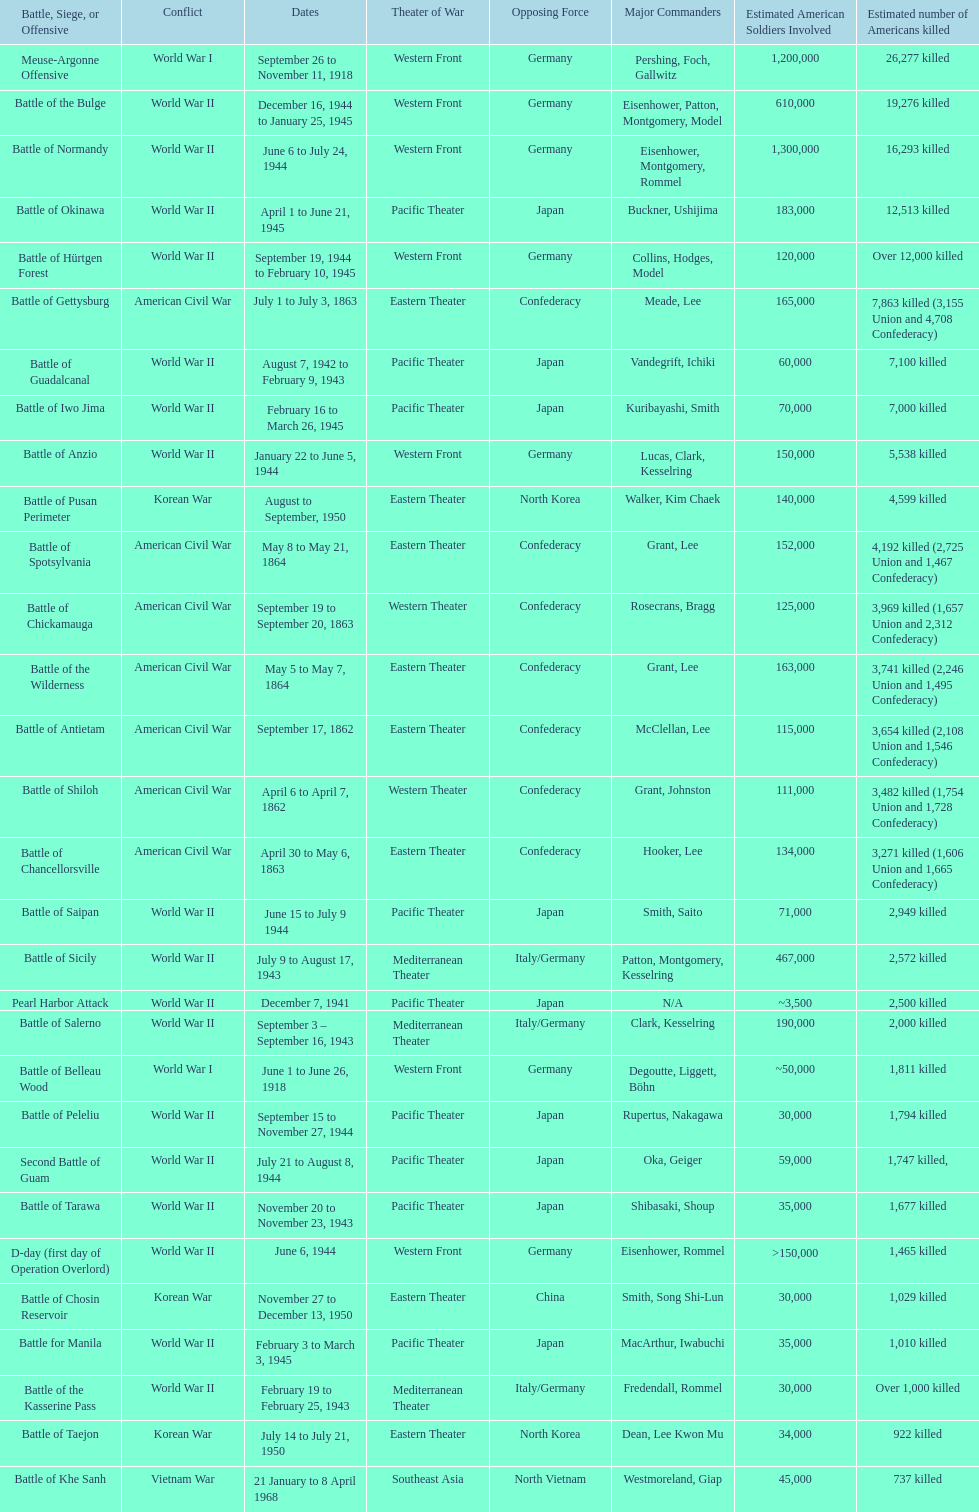How many battles resulted between 3,000 and 4,200 estimated americans killed? 6. Parse the table in full. {'header': ['Battle, Siege, or Offensive', 'Conflict', 'Dates', 'Theater of War', 'Opposing Force', 'Major Commanders', 'Estimated American Soldiers Involved', 'Estimated number of Americans killed'], 'rows': [['Meuse-Argonne Offensive', 'World War I', 'September 26 to November 11, 1918', 'Western Front', 'Germany', 'Pershing, Foch, Gallwitz', '1,200,000', '26,277 killed'], ['Battle of the Bulge', 'World War II', 'December 16, 1944 to January 25, 1945', 'Western Front', 'Germany', 'Eisenhower, Patton, Montgomery, Model', '610,000', '19,276 killed'], ['Battle of Normandy', 'World War II', 'June 6 to July 24, 1944', 'Western Front', 'Germany', 'Eisenhower, Montgomery, Rommel', '1,300,000', '16,293 killed'], ['Battle of Okinawa', 'World War II', 'April 1 to June 21, 1945', 'Pacific Theater', 'Japan', 'Buckner, Ushijima', '183,000', '12,513 killed'], ['Battle of Hürtgen Forest', 'World War II', 'September 19, 1944 to February 10, 1945', 'Western Front', 'Germany', 'Collins, Hodges, Model', '120,000', 'Over 12,000 killed'], ['Battle of Gettysburg', 'American Civil War', 'July 1 to July 3, 1863', 'Eastern Theater', 'Confederacy', 'Meade, Lee', '165,000', '7,863 killed (3,155 Union and 4,708 Confederacy)'], ['Battle of Guadalcanal', 'World War II', 'August 7, 1942 to February 9, 1943', 'Pacific Theater', 'Japan', 'Vandegrift, Ichiki', '60,000', '7,100 killed'], ['Battle of Iwo Jima', 'World War II', 'February 16 to March 26, 1945', 'Pacific Theater', 'Japan', 'Kuribayashi, Smith', '70,000', '7,000 killed'], ['Battle of Anzio', 'World War II', 'January 22 to June 5, 1944', 'Western Front', 'Germany', 'Lucas, Clark, Kesselring', '150,000', '5,538 killed'], ['Battle of Pusan Perimeter', 'Korean War', 'August to September, 1950', 'Eastern Theater', 'North Korea', 'Walker, Kim Chaek', '140,000', '4,599 killed'], ['Battle of Spotsylvania', 'American Civil War', 'May 8 to May 21, 1864', 'Eastern Theater', 'Confederacy', 'Grant, Lee', '152,000', '4,192 killed (2,725 Union and 1,467 Confederacy)'], ['Battle of Chickamauga', 'American Civil War', 'September 19 to September 20, 1863', 'Western Theater', 'Confederacy', 'Rosecrans, Bragg', '125,000', '3,969 killed (1,657 Union and 2,312 Confederacy)'], ['Battle of the Wilderness', 'American Civil War', 'May 5 to May 7, 1864', 'Eastern Theater', 'Confederacy', 'Grant, Lee', '163,000', '3,741 killed (2,246 Union and 1,495 Confederacy)'], ['Battle of Antietam', 'American Civil War', 'September 17, 1862', 'Eastern Theater', 'Confederacy', 'McClellan, Lee', '115,000', '3,654 killed (2,108 Union and 1,546 Confederacy)'], ['Battle of Shiloh', 'American Civil War', 'April 6 to April 7, 1862', 'Western Theater', 'Confederacy', 'Grant, Johnston', '111,000', '3,482 killed (1,754 Union and 1,728 Confederacy)'], ['Battle of Chancellorsville', 'American Civil War', 'April 30 to May 6, 1863', 'Eastern Theater', 'Confederacy', 'Hooker, Lee', '134,000', '3,271 killed (1,606 Union and 1,665 Confederacy)'], ['Battle of Saipan', 'World War II', 'June 15 to July 9 1944', 'Pacific Theater', 'Japan', 'Smith, Saito', '71,000', '2,949 killed'], ['Battle of Sicily', 'World War II', 'July 9 to August 17, 1943', 'Mediterranean Theater', 'Italy/Germany', 'Patton, Montgomery, Kesselring', '467,000', '2,572 killed'], ['Pearl Harbor Attack', 'World War II', 'December 7, 1941', 'Pacific Theater', 'Japan', 'N/A', '~3,500', '2,500 killed'], ['Battle of Salerno', 'World War II', 'September 3 – September 16, 1943', 'Mediterranean Theater', 'Italy/Germany', 'Clark, Kesselring', '190,000', '2,000 killed'], ['Battle of Belleau Wood', 'World War I', 'June 1 to June 26, 1918', 'Western Front', 'Germany', 'Degoutte, Liggett, Böhn', '~50,000', '1,811 killed'], ['Battle of Peleliu', 'World War II', 'September 15 to November 27, 1944', 'Pacific Theater', 'Japan', 'Rupertus, Nakagawa', '30,000', '1,794 killed'], ['Second Battle of Guam', 'World War II', 'July 21 to August 8, 1944', 'Pacific Theater', 'Japan', 'Oka, Geiger', '59,000', '1,747 killed,'], ['Battle of Tarawa', 'World War II', 'November 20 to November 23, 1943', 'Pacific Theater', 'Japan', 'Shibasaki, Shoup', '35,000', '1,677 killed'], ['D-day (first day of Operation Overlord)', 'World War II', 'June 6, 1944', 'Western Front', 'Germany', 'Eisenhower, Rommel', '>150,000', '1,465 killed'], ['Battle of Chosin Reservoir', 'Korean War', 'November 27 to December 13, 1950', 'Eastern Theater', 'China', 'Smith, Song Shi-Lun', '30,000', '1,029 killed'], ['Battle for Manila', 'World War II', 'February 3 to March 3, 1945', 'Pacific Theater', 'Japan', 'MacArthur, Iwabuchi', '35,000', '1,010 killed'], ['Battle of the Kasserine Pass', 'World War II', 'February 19 to February 25, 1943', 'Mediterranean Theater', 'Italy/Germany', 'Fredendall, Rommel', '30,000', 'Over 1,000 killed'], ['Battle of Taejon', 'Korean War', 'July 14 to July 21, 1950', 'Eastern Theater', 'North Korea', 'Dean, Lee Kwon Mu', '34,000', '922 killed'], ['Battle of Khe Sanh', 'Vietnam War', '21 January to 8 April 1968', 'Southeast Asia', 'North Vietnam', 'Westmoreland, Giap', '45,000', '737 killed']]} 